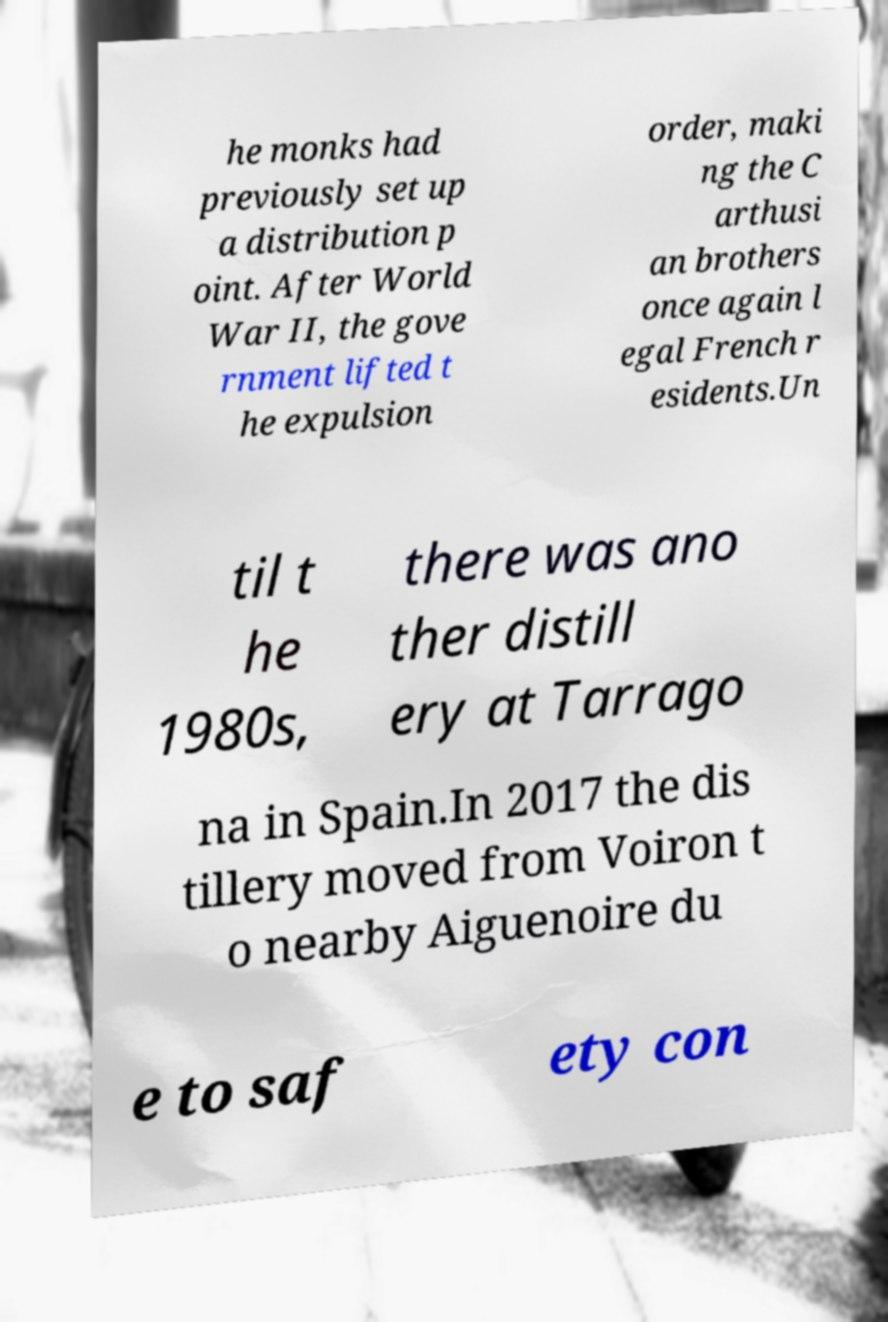Can you accurately transcribe the text from the provided image for me? he monks had previously set up a distribution p oint. After World War II, the gove rnment lifted t he expulsion order, maki ng the C arthusi an brothers once again l egal French r esidents.Un til t he 1980s, there was ano ther distill ery at Tarrago na in Spain.In 2017 the dis tillery moved from Voiron t o nearby Aiguenoire du e to saf ety con 